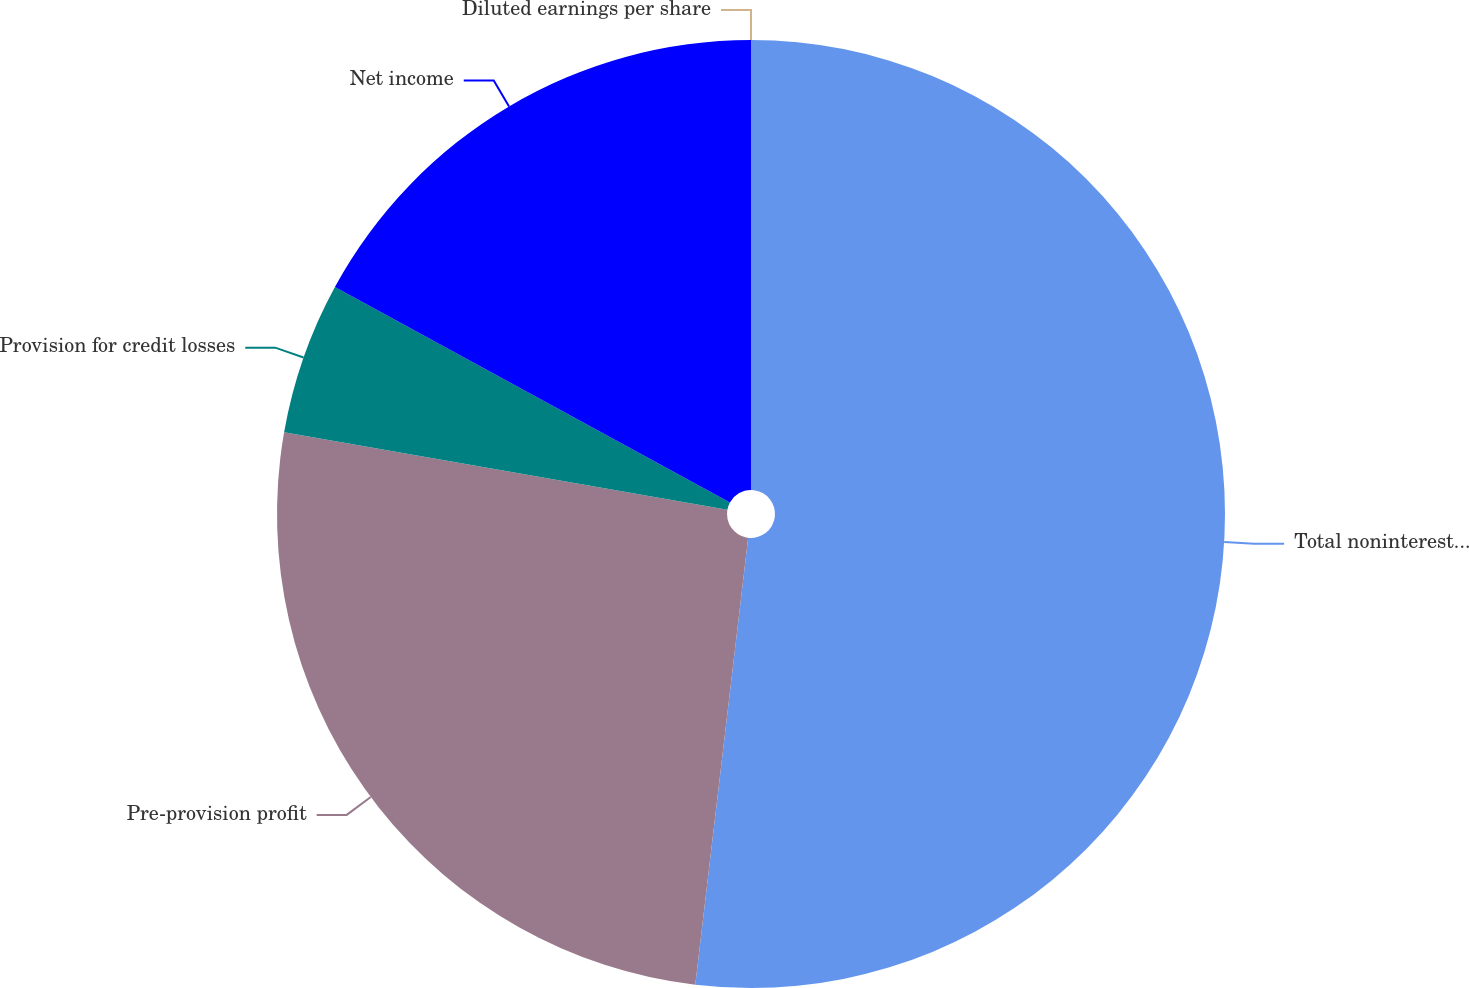<chart> <loc_0><loc_0><loc_500><loc_500><pie_chart><fcel>Total noninterest expense<fcel>Pre-provision profit<fcel>Provision for credit losses<fcel>Net income<fcel>Diluted earnings per share<nl><fcel>51.87%<fcel>25.88%<fcel>5.19%<fcel>17.05%<fcel>0.0%<nl></chart> 